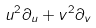<formula> <loc_0><loc_0><loc_500><loc_500>u ^ { 2 } \partial _ { u } + v ^ { 2 } \partial _ { v }</formula> 